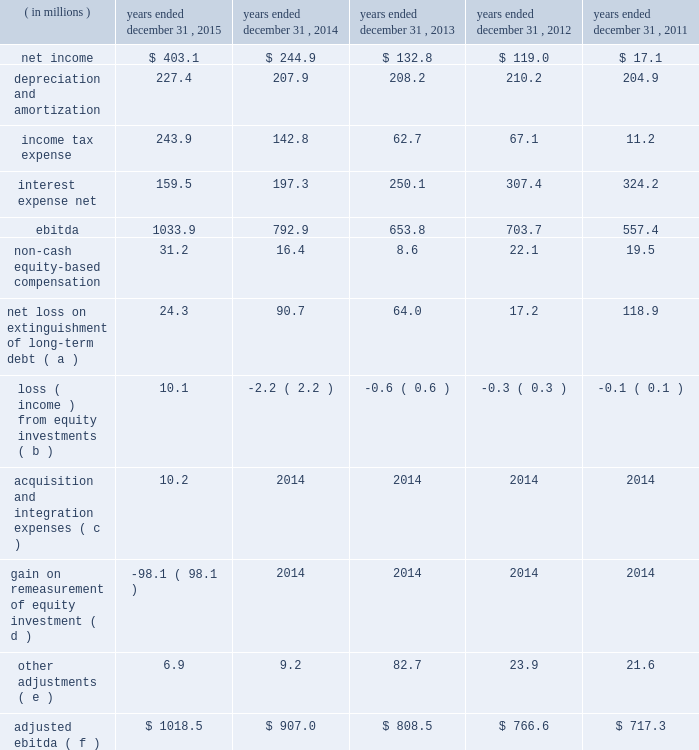Table of contents ( 2 ) includes capitalized lease obligations of $ 3.2 million and $ 0.1 million as of december 31 , 2015 and 2014 , respectively , which are included in other liabilities on the consolidated balance sheet .
( 3 ) ebitda is defined as consolidated net income before interest expense , income tax expense , depreciation and amortization .
Adjusted ebitda , which is a measure defined in our credit agreements , means ebitda adjusted for certain items which are described in the table below .
We have included a reconciliation of ebitda and adjusted ebitda in the table below .
Both ebitda and adjusted ebitda are considered non-gaap financial measures .
Generally , a non-gaap financial measure is a numerical measure of a company 2019s performance , financial position or cash flows that either excludes or includes amounts that are not normally included or excluded in the most directly comparable measure calculated and presented in accordance with gaap .
Non-gaap measures used by us may differ from similar measures used by other companies , even when similar terms are used to identify such measures .
We believe that ebitda and adjusted ebitda provide helpful information with respect to our operating performance and cash flows including our ability to meet our future debt service , capital expenditures and working capital requirements .
Adjusted ebitda is also the primary measure used in certain key covenants and definitions contained in the credit agreement governing our senior secured term loan facility ( 201cterm loan 201d ) , including the excess cash flow payment provision , the restricted payment covenant and the net leverage ratio .
These covenants and definitions are material components of the term loan as they are used in determining the interest rate applicable to the term loan , our ability to make certain investments , incur additional debt , and make restricted payments , such as dividends and share repurchases , as well as whether we are required to make additional principal prepayments on the term loan beyond the quarterly amortization payments .
For further details regarding the term loan , see note 8 ( long-term debt ) to the accompanying consolidated financial statements .
The following unaudited table sets forth reconciliations of net income to ebitda and ebitda to adjusted ebitda for the periods presented: .
Net loss on extinguishment of long-term debt ( a ) 24.3 90.7 64.0 17.2 118.9 loss ( income ) from equity investments ( b ) 10.1 ( 2.2 ) ( 0.6 ) ( 0.3 ) ( 0.1 ) acquisition and integration expenses ( c ) 10.2 2014 2014 2014 2014 gain on remeasurement of equity investment ( d ) ( 98.1 ) 2014 2014 2014 2014 other adjustments ( e ) 6.9 9.2 82.7 23.9 21.6 adjusted ebitda ( f ) $ 1018.5 $ 907.0 $ 808.5 $ 766.6 $ 717.3 ( a ) during the years ended december 31 , 2015 , 2014 , 2013 , 2012 , and 2011 , we recorded net losses on extinguishments of long-term debt .
The losses represented the difference between the amount paid upon extinguishment , including call premiums and expenses paid to the debt holders and agents , and the net carrying amount of the extinguished debt , adjusted for a portion of the unamortized deferred financing costs .
( b ) represents our share of net income/loss from our equity investments .
Our 35% ( 35 % ) share of kelway 2019s net loss includes our 35% ( 35 % ) share of an expense related to certain equity awards granted by one of the sellers to kelway coworkers in july 2015 prior to the acquisition .
( c ) primarily includes expenses related to the acquisition of kelway .
( d ) represents the gain resulting from the remeasurement of our previously held 35% ( 35 % ) equity investment to fair value upon the completion of the acquisition of kelway. .
Did 2015 adjusted ebitda increase more than 2015 actual ebitda? 
Computations: ((1018.5 - 907.0) > (1033.9 - 792.9))
Answer: no. 